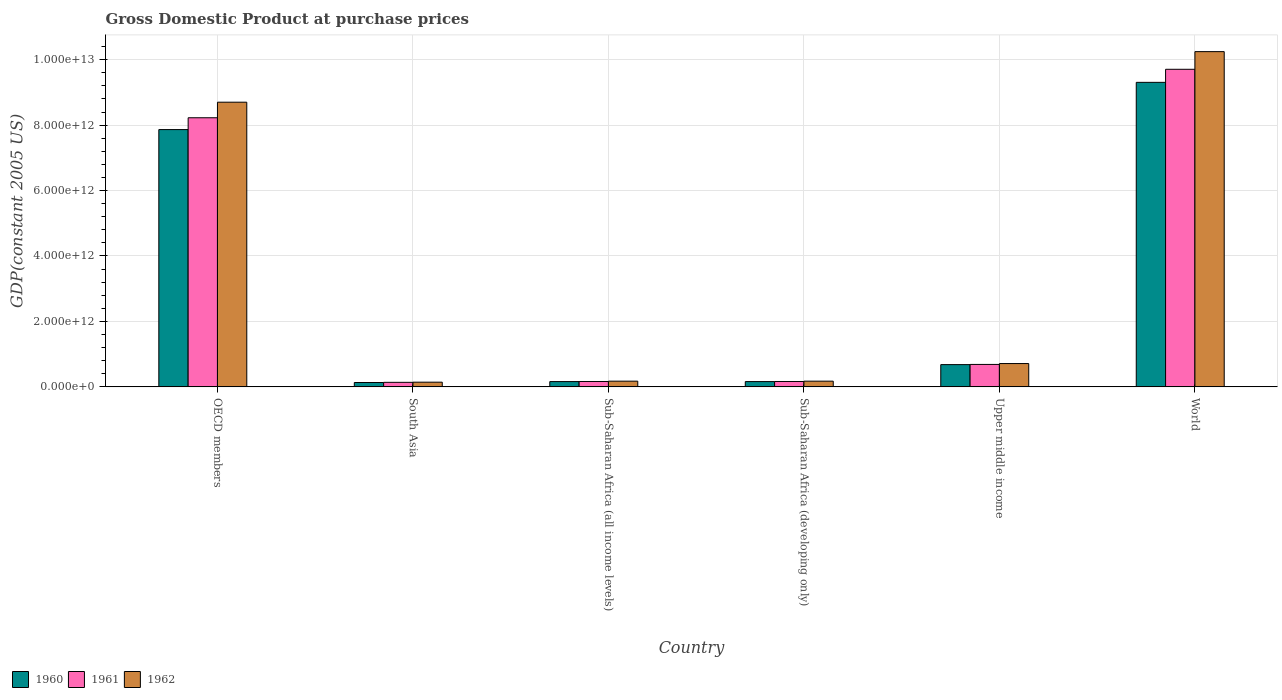How many different coloured bars are there?
Make the answer very short. 3. How many bars are there on the 1st tick from the left?
Offer a terse response. 3. What is the GDP at purchase prices in 1961 in Sub-Saharan Africa (developing only)?
Ensure brevity in your answer.  1.64e+11. Across all countries, what is the maximum GDP at purchase prices in 1961?
Your answer should be compact. 9.71e+12. Across all countries, what is the minimum GDP at purchase prices in 1961?
Make the answer very short. 1.39e+11. What is the total GDP at purchase prices in 1960 in the graph?
Keep it short and to the point. 1.83e+13. What is the difference between the GDP at purchase prices in 1962 in Sub-Saharan Africa (developing only) and that in World?
Provide a short and direct response. -1.01e+13. What is the difference between the GDP at purchase prices in 1962 in South Asia and the GDP at purchase prices in 1960 in Sub-Saharan Africa (developing only)?
Your answer should be compact. -1.81e+1. What is the average GDP at purchase prices in 1961 per country?
Provide a succinct answer. 3.18e+12. What is the difference between the GDP at purchase prices of/in 1961 and GDP at purchase prices of/in 1960 in OECD members?
Offer a terse response. 3.61e+11. In how many countries, is the GDP at purchase prices in 1962 greater than 10000000000000 US$?
Offer a terse response. 1. What is the ratio of the GDP at purchase prices in 1961 in Sub-Saharan Africa (all income levels) to that in Upper middle income?
Your response must be concise. 0.24. Is the GDP at purchase prices in 1961 in Sub-Saharan Africa (all income levels) less than that in Upper middle income?
Provide a short and direct response. Yes. Is the difference between the GDP at purchase prices in 1961 in OECD members and Sub-Saharan Africa (developing only) greater than the difference between the GDP at purchase prices in 1960 in OECD members and Sub-Saharan Africa (developing only)?
Offer a very short reply. Yes. What is the difference between the highest and the second highest GDP at purchase prices in 1961?
Make the answer very short. -9.02e+12. What is the difference between the highest and the lowest GDP at purchase prices in 1962?
Your response must be concise. 1.01e+13. Is the sum of the GDP at purchase prices in 1962 in Sub-Saharan Africa (developing only) and Upper middle income greater than the maximum GDP at purchase prices in 1961 across all countries?
Your answer should be compact. No. What does the 2nd bar from the left in Sub-Saharan Africa (developing only) represents?
Offer a very short reply. 1961. What does the 1st bar from the right in Upper middle income represents?
Your answer should be compact. 1962. How many countries are there in the graph?
Ensure brevity in your answer.  6. What is the difference between two consecutive major ticks on the Y-axis?
Ensure brevity in your answer.  2.00e+12. Are the values on the major ticks of Y-axis written in scientific E-notation?
Your answer should be very brief. Yes. Where does the legend appear in the graph?
Offer a very short reply. Bottom left. How many legend labels are there?
Provide a succinct answer. 3. What is the title of the graph?
Provide a short and direct response. Gross Domestic Product at purchase prices. What is the label or title of the X-axis?
Make the answer very short. Country. What is the label or title of the Y-axis?
Your response must be concise. GDP(constant 2005 US). What is the GDP(constant 2005 US) in 1960 in OECD members?
Ensure brevity in your answer.  7.86e+12. What is the GDP(constant 2005 US) of 1961 in OECD members?
Provide a short and direct response. 8.22e+12. What is the GDP(constant 2005 US) of 1962 in OECD members?
Your response must be concise. 8.70e+12. What is the GDP(constant 2005 US) in 1960 in South Asia?
Your response must be concise. 1.33e+11. What is the GDP(constant 2005 US) in 1961 in South Asia?
Provide a short and direct response. 1.39e+11. What is the GDP(constant 2005 US) in 1962 in South Asia?
Your answer should be very brief. 1.43e+11. What is the GDP(constant 2005 US) in 1960 in Sub-Saharan Africa (all income levels)?
Your answer should be compact. 1.61e+11. What is the GDP(constant 2005 US) of 1961 in Sub-Saharan Africa (all income levels)?
Keep it short and to the point. 1.64e+11. What is the GDP(constant 2005 US) of 1962 in Sub-Saharan Africa (all income levels)?
Give a very brief answer. 1.74e+11. What is the GDP(constant 2005 US) in 1960 in Sub-Saharan Africa (developing only)?
Provide a short and direct response. 1.61e+11. What is the GDP(constant 2005 US) in 1961 in Sub-Saharan Africa (developing only)?
Ensure brevity in your answer.  1.64e+11. What is the GDP(constant 2005 US) in 1962 in Sub-Saharan Africa (developing only)?
Provide a short and direct response. 1.74e+11. What is the GDP(constant 2005 US) in 1960 in Upper middle income?
Provide a short and direct response. 6.80e+11. What is the GDP(constant 2005 US) of 1961 in Upper middle income?
Give a very brief answer. 6.86e+11. What is the GDP(constant 2005 US) in 1962 in Upper middle income?
Ensure brevity in your answer.  7.13e+11. What is the GDP(constant 2005 US) in 1960 in World?
Ensure brevity in your answer.  9.31e+12. What is the GDP(constant 2005 US) of 1961 in World?
Ensure brevity in your answer.  9.71e+12. What is the GDP(constant 2005 US) in 1962 in World?
Give a very brief answer. 1.02e+13. Across all countries, what is the maximum GDP(constant 2005 US) in 1960?
Offer a very short reply. 9.31e+12. Across all countries, what is the maximum GDP(constant 2005 US) in 1961?
Make the answer very short. 9.71e+12. Across all countries, what is the maximum GDP(constant 2005 US) in 1962?
Make the answer very short. 1.02e+13. Across all countries, what is the minimum GDP(constant 2005 US) of 1960?
Keep it short and to the point. 1.33e+11. Across all countries, what is the minimum GDP(constant 2005 US) of 1961?
Offer a very short reply. 1.39e+11. Across all countries, what is the minimum GDP(constant 2005 US) of 1962?
Keep it short and to the point. 1.43e+11. What is the total GDP(constant 2005 US) in 1960 in the graph?
Your response must be concise. 1.83e+13. What is the total GDP(constant 2005 US) of 1961 in the graph?
Keep it short and to the point. 1.91e+13. What is the total GDP(constant 2005 US) of 1962 in the graph?
Your answer should be compact. 2.01e+13. What is the difference between the GDP(constant 2005 US) of 1960 in OECD members and that in South Asia?
Provide a short and direct response. 7.73e+12. What is the difference between the GDP(constant 2005 US) in 1961 in OECD members and that in South Asia?
Your answer should be very brief. 8.09e+12. What is the difference between the GDP(constant 2005 US) in 1962 in OECD members and that in South Asia?
Offer a terse response. 8.56e+12. What is the difference between the GDP(constant 2005 US) of 1960 in OECD members and that in Sub-Saharan Africa (all income levels)?
Provide a short and direct response. 7.70e+12. What is the difference between the GDP(constant 2005 US) of 1961 in OECD members and that in Sub-Saharan Africa (all income levels)?
Your answer should be very brief. 8.06e+12. What is the difference between the GDP(constant 2005 US) of 1962 in OECD members and that in Sub-Saharan Africa (all income levels)?
Keep it short and to the point. 8.53e+12. What is the difference between the GDP(constant 2005 US) in 1960 in OECD members and that in Sub-Saharan Africa (developing only)?
Provide a succinct answer. 7.70e+12. What is the difference between the GDP(constant 2005 US) of 1961 in OECD members and that in Sub-Saharan Africa (developing only)?
Provide a succinct answer. 8.06e+12. What is the difference between the GDP(constant 2005 US) in 1962 in OECD members and that in Sub-Saharan Africa (developing only)?
Your answer should be very brief. 8.53e+12. What is the difference between the GDP(constant 2005 US) in 1960 in OECD members and that in Upper middle income?
Your answer should be compact. 7.18e+12. What is the difference between the GDP(constant 2005 US) in 1961 in OECD members and that in Upper middle income?
Your response must be concise. 7.54e+12. What is the difference between the GDP(constant 2005 US) in 1962 in OECD members and that in Upper middle income?
Offer a very short reply. 7.99e+12. What is the difference between the GDP(constant 2005 US) in 1960 in OECD members and that in World?
Give a very brief answer. -1.44e+12. What is the difference between the GDP(constant 2005 US) in 1961 in OECD members and that in World?
Offer a very short reply. -1.48e+12. What is the difference between the GDP(constant 2005 US) in 1962 in OECD members and that in World?
Offer a terse response. -1.55e+12. What is the difference between the GDP(constant 2005 US) of 1960 in South Asia and that in Sub-Saharan Africa (all income levels)?
Your answer should be very brief. -2.83e+1. What is the difference between the GDP(constant 2005 US) of 1961 in South Asia and that in Sub-Saharan Africa (all income levels)?
Make the answer very short. -2.55e+1. What is the difference between the GDP(constant 2005 US) in 1962 in South Asia and that in Sub-Saharan Africa (all income levels)?
Make the answer very short. -3.10e+1. What is the difference between the GDP(constant 2005 US) in 1960 in South Asia and that in Sub-Saharan Africa (developing only)?
Offer a terse response. -2.83e+1. What is the difference between the GDP(constant 2005 US) of 1961 in South Asia and that in Sub-Saharan Africa (developing only)?
Give a very brief answer. -2.55e+1. What is the difference between the GDP(constant 2005 US) of 1962 in South Asia and that in Sub-Saharan Africa (developing only)?
Ensure brevity in your answer.  -3.10e+1. What is the difference between the GDP(constant 2005 US) in 1960 in South Asia and that in Upper middle income?
Keep it short and to the point. -5.47e+11. What is the difference between the GDP(constant 2005 US) in 1961 in South Asia and that in Upper middle income?
Offer a very short reply. -5.47e+11. What is the difference between the GDP(constant 2005 US) in 1962 in South Asia and that in Upper middle income?
Provide a short and direct response. -5.69e+11. What is the difference between the GDP(constant 2005 US) of 1960 in South Asia and that in World?
Offer a very short reply. -9.17e+12. What is the difference between the GDP(constant 2005 US) in 1961 in South Asia and that in World?
Ensure brevity in your answer.  -9.57e+12. What is the difference between the GDP(constant 2005 US) of 1962 in South Asia and that in World?
Make the answer very short. -1.01e+13. What is the difference between the GDP(constant 2005 US) of 1960 in Sub-Saharan Africa (all income levels) and that in Sub-Saharan Africa (developing only)?
Offer a terse response. 6.39e+07. What is the difference between the GDP(constant 2005 US) in 1961 in Sub-Saharan Africa (all income levels) and that in Sub-Saharan Africa (developing only)?
Make the answer very short. 5.44e+07. What is the difference between the GDP(constant 2005 US) in 1962 in Sub-Saharan Africa (all income levels) and that in Sub-Saharan Africa (developing only)?
Ensure brevity in your answer.  6.12e+07. What is the difference between the GDP(constant 2005 US) of 1960 in Sub-Saharan Africa (all income levels) and that in Upper middle income?
Offer a terse response. -5.19e+11. What is the difference between the GDP(constant 2005 US) in 1961 in Sub-Saharan Africa (all income levels) and that in Upper middle income?
Make the answer very short. -5.22e+11. What is the difference between the GDP(constant 2005 US) of 1962 in Sub-Saharan Africa (all income levels) and that in Upper middle income?
Make the answer very short. -5.38e+11. What is the difference between the GDP(constant 2005 US) of 1960 in Sub-Saharan Africa (all income levels) and that in World?
Give a very brief answer. -9.14e+12. What is the difference between the GDP(constant 2005 US) of 1961 in Sub-Saharan Africa (all income levels) and that in World?
Your answer should be very brief. -9.54e+12. What is the difference between the GDP(constant 2005 US) of 1962 in Sub-Saharan Africa (all income levels) and that in World?
Make the answer very short. -1.01e+13. What is the difference between the GDP(constant 2005 US) in 1960 in Sub-Saharan Africa (developing only) and that in Upper middle income?
Your answer should be very brief. -5.19e+11. What is the difference between the GDP(constant 2005 US) of 1961 in Sub-Saharan Africa (developing only) and that in Upper middle income?
Your response must be concise. -5.22e+11. What is the difference between the GDP(constant 2005 US) in 1962 in Sub-Saharan Africa (developing only) and that in Upper middle income?
Offer a terse response. -5.38e+11. What is the difference between the GDP(constant 2005 US) of 1960 in Sub-Saharan Africa (developing only) and that in World?
Your response must be concise. -9.14e+12. What is the difference between the GDP(constant 2005 US) of 1961 in Sub-Saharan Africa (developing only) and that in World?
Your answer should be very brief. -9.54e+12. What is the difference between the GDP(constant 2005 US) in 1962 in Sub-Saharan Africa (developing only) and that in World?
Provide a succinct answer. -1.01e+13. What is the difference between the GDP(constant 2005 US) in 1960 in Upper middle income and that in World?
Ensure brevity in your answer.  -8.63e+12. What is the difference between the GDP(constant 2005 US) of 1961 in Upper middle income and that in World?
Your answer should be very brief. -9.02e+12. What is the difference between the GDP(constant 2005 US) of 1962 in Upper middle income and that in World?
Your answer should be compact. -9.53e+12. What is the difference between the GDP(constant 2005 US) of 1960 in OECD members and the GDP(constant 2005 US) of 1961 in South Asia?
Give a very brief answer. 7.72e+12. What is the difference between the GDP(constant 2005 US) in 1960 in OECD members and the GDP(constant 2005 US) in 1962 in South Asia?
Offer a terse response. 7.72e+12. What is the difference between the GDP(constant 2005 US) in 1961 in OECD members and the GDP(constant 2005 US) in 1962 in South Asia?
Keep it short and to the point. 8.08e+12. What is the difference between the GDP(constant 2005 US) of 1960 in OECD members and the GDP(constant 2005 US) of 1961 in Sub-Saharan Africa (all income levels)?
Your answer should be compact. 7.70e+12. What is the difference between the GDP(constant 2005 US) of 1960 in OECD members and the GDP(constant 2005 US) of 1962 in Sub-Saharan Africa (all income levels)?
Make the answer very short. 7.69e+12. What is the difference between the GDP(constant 2005 US) in 1961 in OECD members and the GDP(constant 2005 US) in 1962 in Sub-Saharan Africa (all income levels)?
Keep it short and to the point. 8.05e+12. What is the difference between the GDP(constant 2005 US) in 1960 in OECD members and the GDP(constant 2005 US) in 1961 in Sub-Saharan Africa (developing only)?
Offer a terse response. 7.70e+12. What is the difference between the GDP(constant 2005 US) of 1960 in OECD members and the GDP(constant 2005 US) of 1962 in Sub-Saharan Africa (developing only)?
Provide a short and direct response. 7.69e+12. What is the difference between the GDP(constant 2005 US) of 1961 in OECD members and the GDP(constant 2005 US) of 1962 in Sub-Saharan Africa (developing only)?
Give a very brief answer. 8.05e+12. What is the difference between the GDP(constant 2005 US) of 1960 in OECD members and the GDP(constant 2005 US) of 1961 in Upper middle income?
Ensure brevity in your answer.  7.18e+12. What is the difference between the GDP(constant 2005 US) in 1960 in OECD members and the GDP(constant 2005 US) in 1962 in Upper middle income?
Ensure brevity in your answer.  7.15e+12. What is the difference between the GDP(constant 2005 US) in 1961 in OECD members and the GDP(constant 2005 US) in 1962 in Upper middle income?
Give a very brief answer. 7.51e+12. What is the difference between the GDP(constant 2005 US) of 1960 in OECD members and the GDP(constant 2005 US) of 1961 in World?
Ensure brevity in your answer.  -1.84e+12. What is the difference between the GDP(constant 2005 US) in 1960 in OECD members and the GDP(constant 2005 US) in 1962 in World?
Offer a terse response. -2.38e+12. What is the difference between the GDP(constant 2005 US) in 1961 in OECD members and the GDP(constant 2005 US) in 1962 in World?
Keep it short and to the point. -2.02e+12. What is the difference between the GDP(constant 2005 US) in 1960 in South Asia and the GDP(constant 2005 US) in 1961 in Sub-Saharan Africa (all income levels)?
Offer a very short reply. -3.11e+1. What is the difference between the GDP(constant 2005 US) of 1960 in South Asia and the GDP(constant 2005 US) of 1962 in Sub-Saharan Africa (all income levels)?
Ensure brevity in your answer.  -4.12e+1. What is the difference between the GDP(constant 2005 US) in 1961 in South Asia and the GDP(constant 2005 US) in 1962 in Sub-Saharan Africa (all income levels)?
Give a very brief answer. -3.57e+1. What is the difference between the GDP(constant 2005 US) in 1960 in South Asia and the GDP(constant 2005 US) in 1961 in Sub-Saharan Africa (developing only)?
Your answer should be very brief. -3.10e+1. What is the difference between the GDP(constant 2005 US) of 1960 in South Asia and the GDP(constant 2005 US) of 1962 in Sub-Saharan Africa (developing only)?
Offer a very short reply. -4.11e+1. What is the difference between the GDP(constant 2005 US) in 1961 in South Asia and the GDP(constant 2005 US) in 1962 in Sub-Saharan Africa (developing only)?
Offer a terse response. -3.56e+1. What is the difference between the GDP(constant 2005 US) of 1960 in South Asia and the GDP(constant 2005 US) of 1961 in Upper middle income?
Provide a succinct answer. -5.53e+11. What is the difference between the GDP(constant 2005 US) in 1960 in South Asia and the GDP(constant 2005 US) in 1962 in Upper middle income?
Offer a very short reply. -5.79e+11. What is the difference between the GDP(constant 2005 US) of 1961 in South Asia and the GDP(constant 2005 US) of 1962 in Upper middle income?
Your response must be concise. -5.74e+11. What is the difference between the GDP(constant 2005 US) of 1960 in South Asia and the GDP(constant 2005 US) of 1961 in World?
Keep it short and to the point. -9.57e+12. What is the difference between the GDP(constant 2005 US) of 1960 in South Asia and the GDP(constant 2005 US) of 1962 in World?
Give a very brief answer. -1.01e+13. What is the difference between the GDP(constant 2005 US) of 1961 in South Asia and the GDP(constant 2005 US) of 1962 in World?
Provide a short and direct response. -1.01e+13. What is the difference between the GDP(constant 2005 US) of 1960 in Sub-Saharan Africa (all income levels) and the GDP(constant 2005 US) of 1961 in Sub-Saharan Africa (developing only)?
Ensure brevity in your answer.  -2.68e+09. What is the difference between the GDP(constant 2005 US) in 1960 in Sub-Saharan Africa (all income levels) and the GDP(constant 2005 US) in 1962 in Sub-Saharan Africa (developing only)?
Offer a terse response. -1.28e+1. What is the difference between the GDP(constant 2005 US) in 1961 in Sub-Saharan Africa (all income levels) and the GDP(constant 2005 US) in 1962 in Sub-Saharan Africa (developing only)?
Your answer should be compact. -1.00e+1. What is the difference between the GDP(constant 2005 US) of 1960 in Sub-Saharan Africa (all income levels) and the GDP(constant 2005 US) of 1961 in Upper middle income?
Give a very brief answer. -5.25e+11. What is the difference between the GDP(constant 2005 US) of 1960 in Sub-Saharan Africa (all income levels) and the GDP(constant 2005 US) of 1962 in Upper middle income?
Keep it short and to the point. -5.51e+11. What is the difference between the GDP(constant 2005 US) of 1961 in Sub-Saharan Africa (all income levels) and the GDP(constant 2005 US) of 1962 in Upper middle income?
Your answer should be very brief. -5.48e+11. What is the difference between the GDP(constant 2005 US) of 1960 in Sub-Saharan Africa (all income levels) and the GDP(constant 2005 US) of 1961 in World?
Ensure brevity in your answer.  -9.54e+12. What is the difference between the GDP(constant 2005 US) of 1960 in Sub-Saharan Africa (all income levels) and the GDP(constant 2005 US) of 1962 in World?
Your answer should be very brief. -1.01e+13. What is the difference between the GDP(constant 2005 US) in 1961 in Sub-Saharan Africa (all income levels) and the GDP(constant 2005 US) in 1962 in World?
Make the answer very short. -1.01e+13. What is the difference between the GDP(constant 2005 US) in 1960 in Sub-Saharan Africa (developing only) and the GDP(constant 2005 US) in 1961 in Upper middle income?
Offer a terse response. -5.25e+11. What is the difference between the GDP(constant 2005 US) of 1960 in Sub-Saharan Africa (developing only) and the GDP(constant 2005 US) of 1962 in Upper middle income?
Give a very brief answer. -5.51e+11. What is the difference between the GDP(constant 2005 US) of 1961 in Sub-Saharan Africa (developing only) and the GDP(constant 2005 US) of 1962 in Upper middle income?
Offer a terse response. -5.48e+11. What is the difference between the GDP(constant 2005 US) in 1960 in Sub-Saharan Africa (developing only) and the GDP(constant 2005 US) in 1961 in World?
Your answer should be compact. -9.54e+12. What is the difference between the GDP(constant 2005 US) of 1960 in Sub-Saharan Africa (developing only) and the GDP(constant 2005 US) of 1962 in World?
Make the answer very short. -1.01e+13. What is the difference between the GDP(constant 2005 US) in 1961 in Sub-Saharan Africa (developing only) and the GDP(constant 2005 US) in 1962 in World?
Make the answer very short. -1.01e+13. What is the difference between the GDP(constant 2005 US) in 1960 in Upper middle income and the GDP(constant 2005 US) in 1961 in World?
Offer a very short reply. -9.03e+12. What is the difference between the GDP(constant 2005 US) of 1960 in Upper middle income and the GDP(constant 2005 US) of 1962 in World?
Keep it short and to the point. -9.56e+12. What is the difference between the GDP(constant 2005 US) of 1961 in Upper middle income and the GDP(constant 2005 US) of 1962 in World?
Give a very brief answer. -9.56e+12. What is the average GDP(constant 2005 US) of 1960 per country?
Offer a terse response. 3.05e+12. What is the average GDP(constant 2005 US) in 1961 per country?
Offer a very short reply. 3.18e+12. What is the average GDP(constant 2005 US) of 1962 per country?
Provide a short and direct response. 3.36e+12. What is the difference between the GDP(constant 2005 US) in 1960 and GDP(constant 2005 US) in 1961 in OECD members?
Give a very brief answer. -3.61e+11. What is the difference between the GDP(constant 2005 US) of 1960 and GDP(constant 2005 US) of 1962 in OECD members?
Offer a very short reply. -8.37e+11. What is the difference between the GDP(constant 2005 US) in 1961 and GDP(constant 2005 US) in 1962 in OECD members?
Offer a very short reply. -4.75e+11. What is the difference between the GDP(constant 2005 US) in 1960 and GDP(constant 2005 US) in 1961 in South Asia?
Your answer should be very brief. -5.51e+09. What is the difference between the GDP(constant 2005 US) of 1960 and GDP(constant 2005 US) of 1962 in South Asia?
Make the answer very short. -1.01e+1. What is the difference between the GDP(constant 2005 US) in 1961 and GDP(constant 2005 US) in 1962 in South Asia?
Keep it short and to the point. -4.63e+09. What is the difference between the GDP(constant 2005 US) in 1960 and GDP(constant 2005 US) in 1961 in Sub-Saharan Africa (all income levels)?
Keep it short and to the point. -2.73e+09. What is the difference between the GDP(constant 2005 US) of 1960 and GDP(constant 2005 US) of 1962 in Sub-Saharan Africa (all income levels)?
Your response must be concise. -1.28e+1. What is the difference between the GDP(constant 2005 US) in 1961 and GDP(constant 2005 US) in 1962 in Sub-Saharan Africa (all income levels)?
Make the answer very short. -1.01e+1. What is the difference between the GDP(constant 2005 US) in 1960 and GDP(constant 2005 US) in 1961 in Sub-Saharan Africa (developing only)?
Keep it short and to the point. -2.74e+09. What is the difference between the GDP(constant 2005 US) in 1960 and GDP(constant 2005 US) in 1962 in Sub-Saharan Africa (developing only)?
Your answer should be very brief. -1.28e+1. What is the difference between the GDP(constant 2005 US) of 1961 and GDP(constant 2005 US) of 1962 in Sub-Saharan Africa (developing only)?
Your response must be concise. -1.01e+1. What is the difference between the GDP(constant 2005 US) in 1960 and GDP(constant 2005 US) in 1961 in Upper middle income?
Your response must be concise. -6.01e+09. What is the difference between the GDP(constant 2005 US) of 1960 and GDP(constant 2005 US) of 1962 in Upper middle income?
Offer a terse response. -3.26e+1. What is the difference between the GDP(constant 2005 US) of 1961 and GDP(constant 2005 US) of 1962 in Upper middle income?
Provide a succinct answer. -2.66e+1. What is the difference between the GDP(constant 2005 US) of 1960 and GDP(constant 2005 US) of 1961 in World?
Ensure brevity in your answer.  -3.99e+11. What is the difference between the GDP(constant 2005 US) of 1960 and GDP(constant 2005 US) of 1962 in World?
Ensure brevity in your answer.  -9.39e+11. What is the difference between the GDP(constant 2005 US) of 1961 and GDP(constant 2005 US) of 1962 in World?
Offer a very short reply. -5.39e+11. What is the ratio of the GDP(constant 2005 US) in 1960 in OECD members to that in South Asia?
Offer a terse response. 59.05. What is the ratio of the GDP(constant 2005 US) of 1961 in OECD members to that in South Asia?
Your answer should be very brief. 59.31. What is the ratio of the GDP(constant 2005 US) in 1962 in OECD members to that in South Asia?
Ensure brevity in your answer.  60.71. What is the ratio of the GDP(constant 2005 US) of 1960 in OECD members to that in Sub-Saharan Africa (all income levels)?
Make the answer very short. 48.69. What is the ratio of the GDP(constant 2005 US) in 1961 in OECD members to that in Sub-Saharan Africa (all income levels)?
Your answer should be compact. 50.08. What is the ratio of the GDP(constant 2005 US) of 1962 in OECD members to that in Sub-Saharan Africa (all income levels)?
Ensure brevity in your answer.  49.91. What is the ratio of the GDP(constant 2005 US) in 1960 in OECD members to that in Sub-Saharan Africa (developing only)?
Your answer should be very brief. 48.71. What is the ratio of the GDP(constant 2005 US) in 1961 in OECD members to that in Sub-Saharan Africa (developing only)?
Give a very brief answer. 50.1. What is the ratio of the GDP(constant 2005 US) in 1962 in OECD members to that in Sub-Saharan Africa (developing only)?
Provide a succinct answer. 49.92. What is the ratio of the GDP(constant 2005 US) of 1960 in OECD members to that in Upper middle income?
Keep it short and to the point. 11.56. What is the ratio of the GDP(constant 2005 US) of 1961 in OECD members to that in Upper middle income?
Offer a terse response. 11.99. What is the ratio of the GDP(constant 2005 US) of 1962 in OECD members to that in Upper middle income?
Offer a very short reply. 12.21. What is the ratio of the GDP(constant 2005 US) in 1960 in OECD members to that in World?
Your answer should be compact. 0.84. What is the ratio of the GDP(constant 2005 US) of 1961 in OECD members to that in World?
Your response must be concise. 0.85. What is the ratio of the GDP(constant 2005 US) of 1962 in OECD members to that in World?
Offer a very short reply. 0.85. What is the ratio of the GDP(constant 2005 US) in 1960 in South Asia to that in Sub-Saharan Africa (all income levels)?
Offer a terse response. 0.82. What is the ratio of the GDP(constant 2005 US) in 1961 in South Asia to that in Sub-Saharan Africa (all income levels)?
Your answer should be compact. 0.84. What is the ratio of the GDP(constant 2005 US) in 1962 in South Asia to that in Sub-Saharan Africa (all income levels)?
Provide a short and direct response. 0.82. What is the ratio of the GDP(constant 2005 US) of 1960 in South Asia to that in Sub-Saharan Africa (developing only)?
Offer a very short reply. 0.82. What is the ratio of the GDP(constant 2005 US) in 1961 in South Asia to that in Sub-Saharan Africa (developing only)?
Keep it short and to the point. 0.84. What is the ratio of the GDP(constant 2005 US) of 1962 in South Asia to that in Sub-Saharan Africa (developing only)?
Provide a short and direct response. 0.82. What is the ratio of the GDP(constant 2005 US) in 1960 in South Asia to that in Upper middle income?
Give a very brief answer. 0.2. What is the ratio of the GDP(constant 2005 US) in 1961 in South Asia to that in Upper middle income?
Offer a terse response. 0.2. What is the ratio of the GDP(constant 2005 US) of 1962 in South Asia to that in Upper middle income?
Keep it short and to the point. 0.2. What is the ratio of the GDP(constant 2005 US) of 1960 in South Asia to that in World?
Your answer should be very brief. 0.01. What is the ratio of the GDP(constant 2005 US) in 1961 in South Asia to that in World?
Offer a terse response. 0.01. What is the ratio of the GDP(constant 2005 US) of 1962 in South Asia to that in World?
Offer a very short reply. 0.01. What is the ratio of the GDP(constant 2005 US) of 1960 in Sub-Saharan Africa (all income levels) to that in Sub-Saharan Africa (developing only)?
Your response must be concise. 1. What is the ratio of the GDP(constant 2005 US) of 1962 in Sub-Saharan Africa (all income levels) to that in Sub-Saharan Africa (developing only)?
Offer a terse response. 1. What is the ratio of the GDP(constant 2005 US) in 1960 in Sub-Saharan Africa (all income levels) to that in Upper middle income?
Provide a short and direct response. 0.24. What is the ratio of the GDP(constant 2005 US) in 1961 in Sub-Saharan Africa (all income levels) to that in Upper middle income?
Ensure brevity in your answer.  0.24. What is the ratio of the GDP(constant 2005 US) of 1962 in Sub-Saharan Africa (all income levels) to that in Upper middle income?
Give a very brief answer. 0.24. What is the ratio of the GDP(constant 2005 US) of 1960 in Sub-Saharan Africa (all income levels) to that in World?
Ensure brevity in your answer.  0.02. What is the ratio of the GDP(constant 2005 US) of 1961 in Sub-Saharan Africa (all income levels) to that in World?
Offer a very short reply. 0.02. What is the ratio of the GDP(constant 2005 US) in 1962 in Sub-Saharan Africa (all income levels) to that in World?
Your answer should be compact. 0.02. What is the ratio of the GDP(constant 2005 US) in 1960 in Sub-Saharan Africa (developing only) to that in Upper middle income?
Your answer should be compact. 0.24. What is the ratio of the GDP(constant 2005 US) of 1961 in Sub-Saharan Africa (developing only) to that in Upper middle income?
Offer a very short reply. 0.24. What is the ratio of the GDP(constant 2005 US) of 1962 in Sub-Saharan Africa (developing only) to that in Upper middle income?
Offer a very short reply. 0.24. What is the ratio of the GDP(constant 2005 US) in 1960 in Sub-Saharan Africa (developing only) to that in World?
Your response must be concise. 0.02. What is the ratio of the GDP(constant 2005 US) of 1961 in Sub-Saharan Africa (developing only) to that in World?
Offer a terse response. 0.02. What is the ratio of the GDP(constant 2005 US) in 1962 in Sub-Saharan Africa (developing only) to that in World?
Your answer should be compact. 0.02. What is the ratio of the GDP(constant 2005 US) in 1960 in Upper middle income to that in World?
Offer a terse response. 0.07. What is the ratio of the GDP(constant 2005 US) in 1961 in Upper middle income to that in World?
Make the answer very short. 0.07. What is the ratio of the GDP(constant 2005 US) of 1962 in Upper middle income to that in World?
Ensure brevity in your answer.  0.07. What is the difference between the highest and the second highest GDP(constant 2005 US) of 1960?
Ensure brevity in your answer.  1.44e+12. What is the difference between the highest and the second highest GDP(constant 2005 US) of 1961?
Your response must be concise. 1.48e+12. What is the difference between the highest and the second highest GDP(constant 2005 US) in 1962?
Your response must be concise. 1.55e+12. What is the difference between the highest and the lowest GDP(constant 2005 US) in 1960?
Provide a succinct answer. 9.17e+12. What is the difference between the highest and the lowest GDP(constant 2005 US) in 1961?
Offer a terse response. 9.57e+12. What is the difference between the highest and the lowest GDP(constant 2005 US) in 1962?
Offer a very short reply. 1.01e+13. 